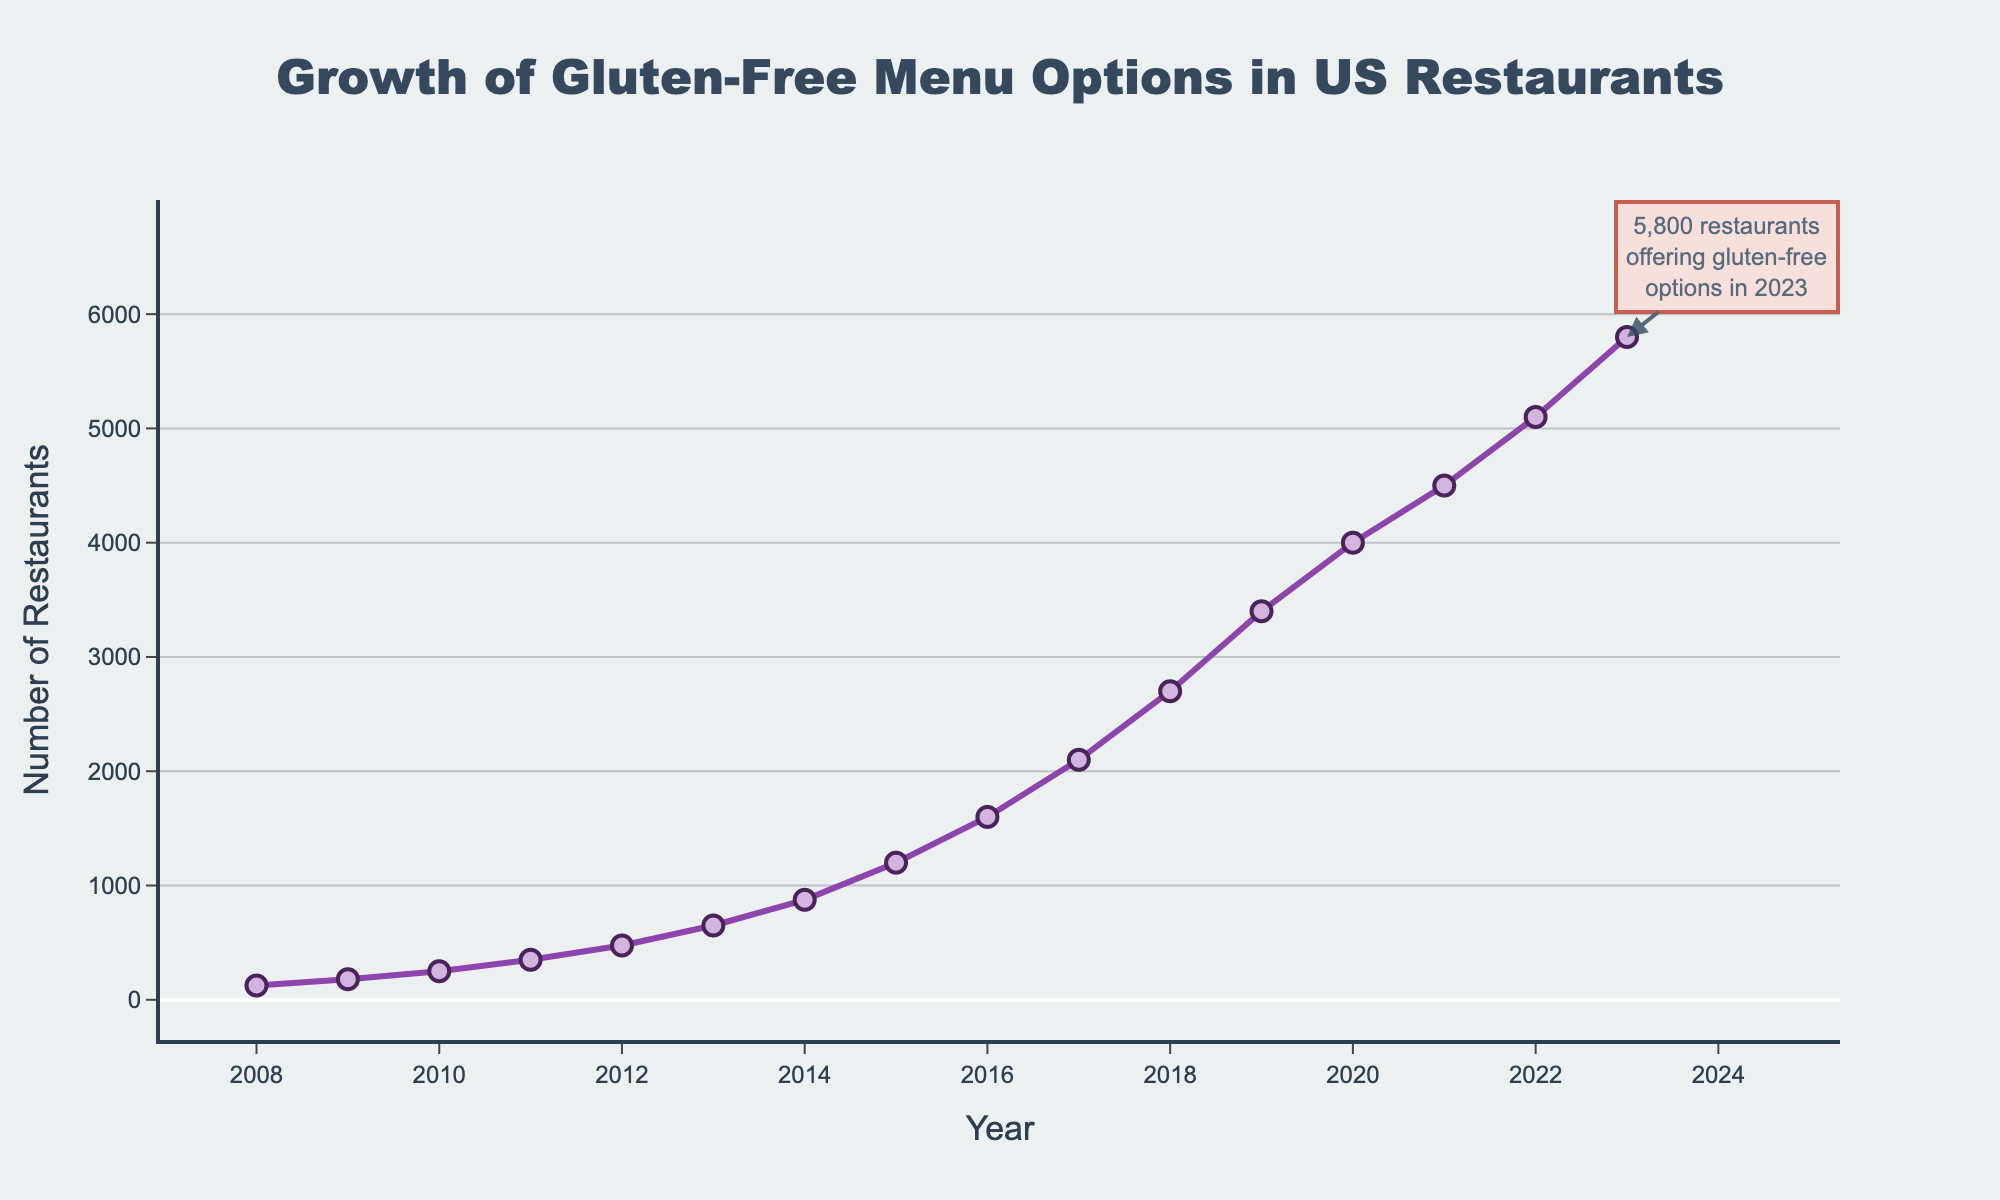What is the number of restaurants offering gluten-free options in 2015? Look at the y-axis value for the year 2015. It shows 1200 restaurants.
Answer: 1200 How many more restaurants offered gluten-free options in 2023 than in 2008? The number in 2023 is 5800 and in 2008 is 125. Subtract 125 from 5800 to find the difference: 5800 - 125 = 5675.
Answer: 5675 By how much did the number of restaurants offering gluten-free options increase between 2010 and 2013? In 2010, the number is 250 and in 2013, it is 650. Subtract 250 from 650 to find the difference: 650 - 250 = 400.
Answer: 400 Which year shows the highest increase in the number of restaurants offering gluten-free options? Compare the increase in numbers from one year to the next across all years. The largest increase is from 2018 (2700) to 2019 (3400), which is an increase of 700.
Answer: 2019 What's the average number of restaurants offering gluten-free options from 2008 to 2011? Add the numbers from 2008, 2009, 2010, and 2011: 125 + 180 + 250 + 350 = 905. Then divide by 4: 905 / 4 = 226.25.
Answer: 226.25 Between which consecutive years did the number of restaurants jump by approximately 500? Look at changes between each pair of consecutive years. The jump from 2013 (650) to 2014 (875) is 875 - 650 = 225, from 2019 (3400) to 2020 (4000) is 4000 - 3400 = 600. The closest jump to 500 is from 2019 to 2020.
Answer: 2019-2020 How many times did the number of restaurants double over the 15-year period? Starting from 2008 with 125 restaurants, doubling would be 250 (reached in 2010), then 500 (almost reached by 2012 with 475), 1000 (reached by 2015 with 1200), 2000 (crossed by 2017 with 2100), and 4000 (reached by 2020). This happened 4 times.
Answer: 4 If the trend continues, estimate the number of restaurants offering gluten-free options in 2025. The trend shows an increasing pattern. From 2022 to 2023, it increased by 700. Assuming a similar increase, adding another two years to 2023, the estimate would be 5800 + 700 + 700 = 7200.
Answer: 7200 